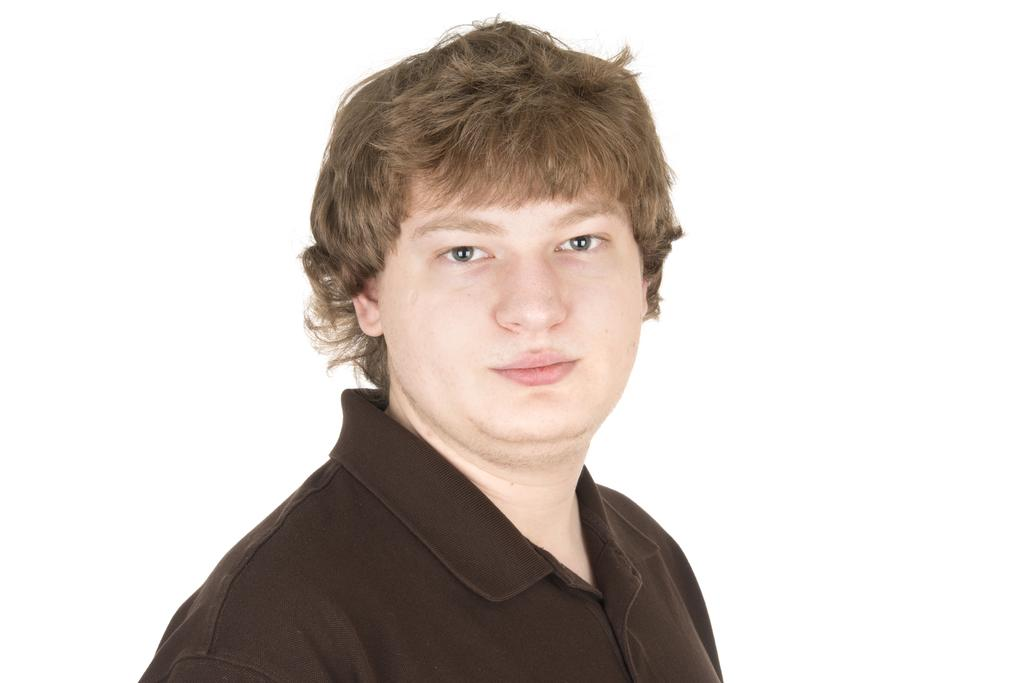What is the main subject of the image? There is a person in the image. What is the person wearing in the image? The person is wearing a brown t-shirt. What is the color of the background in the image? There is a white background in the image. How many chairs are visible in the image? There are no chairs present in the image. What type of record is being played in the image? There is no record or music player present in the image. 